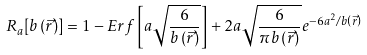<formula> <loc_0><loc_0><loc_500><loc_500>R _ { a } [ b \left ( \vec { r } \right ) ] = 1 - E r f \left [ a \sqrt { \frac { 6 } { b \left ( \vec { r } \right ) } } \right ] + 2 a \sqrt { \frac { 6 } { \pi b \left ( \vec { r } \right ) } } e ^ { - 6 a ^ { 2 } / b \left ( \vec { r } \right ) }</formula> 